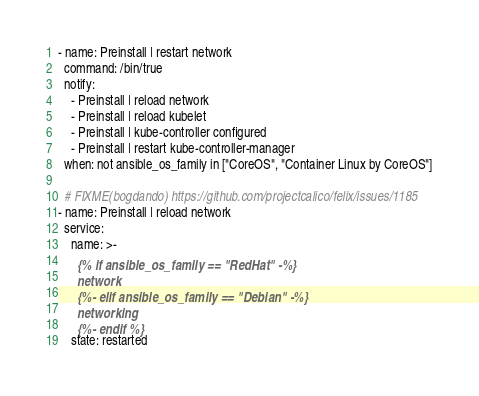<code> <loc_0><loc_0><loc_500><loc_500><_YAML_>- name: Preinstall | restart network
  command: /bin/true
  notify:
    - Preinstall | reload network
    - Preinstall | reload kubelet
    - Preinstall | kube-controller configured
    - Preinstall | restart kube-controller-manager
  when: not ansible_os_family in ["CoreOS", "Container Linux by CoreOS"]

  # FIXME(bogdando) https://github.com/projectcalico/felix/issues/1185
- name: Preinstall | reload network
  service:
    name: >-
      {% if ansible_os_family == "RedHat" -%}
      network
      {%- elif ansible_os_family == "Debian" -%}
      networking
      {%- endif %}
    state: restarted</code> 